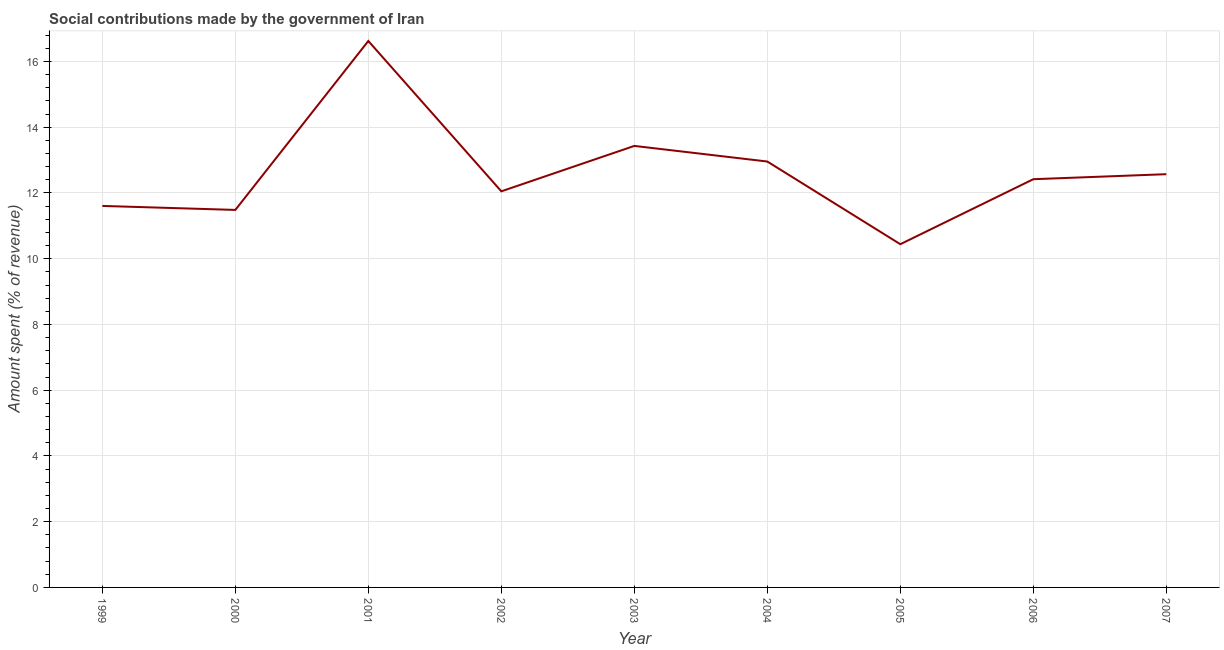What is the amount spent in making social contributions in 2005?
Your answer should be compact. 10.44. Across all years, what is the maximum amount spent in making social contributions?
Provide a short and direct response. 16.62. Across all years, what is the minimum amount spent in making social contributions?
Provide a succinct answer. 10.44. What is the sum of the amount spent in making social contributions?
Your response must be concise. 113.58. What is the difference between the amount spent in making social contributions in 2005 and 2006?
Your response must be concise. -1.98. What is the average amount spent in making social contributions per year?
Keep it short and to the point. 12.62. What is the median amount spent in making social contributions?
Make the answer very short. 12.42. In how many years, is the amount spent in making social contributions greater than 14.4 %?
Keep it short and to the point. 1. What is the ratio of the amount spent in making social contributions in 2000 to that in 2001?
Provide a succinct answer. 0.69. Is the amount spent in making social contributions in 2001 less than that in 2006?
Make the answer very short. No. What is the difference between the highest and the second highest amount spent in making social contributions?
Give a very brief answer. 3.19. What is the difference between the highest and the lowest amount spent in making social contributions?
Ensure brevity in your answer.  6.18. Does the amount spent in making social contributions monotonically increase over the years?
Provide a succinct answer. No. How many lines are there?
Ensure brevity in your answer.  1. Does the graph contain grids?
Offer a very short reply. Yes. What is the title of the graph?
Give a very brief answer. Social contributions made by the government of Iran. What is the label or title of the X-axis?
Give a very brief answer. Year. What is the label or title of the Y-axis?
Provide a short and direct response. Amount spent (% of revenue). What is the Amount spent (% of revenue) of 1999?
Give a very brief answer. 11.61. What is the Amount spent (% of revenue) in 2000?
Offer a very short reply. 11.48. What is the Amount spent (% of revenue) of 2001?
Offer a terse response. 16.62. What is the Amount spent (% of revenue) in 2002?
Keep it short and to the point. 12.05. What is the Amount spent (% of revenue) in 2003?
Offer a terse response. 13.43. What is the Amount spent (% of revenue) of 2004?
Offer a very short reply. 12.96. What is the Amount spent (% of revenue) in 2005?
Your response must be concise. 10.44. What is the Amount spent (% of revenue) in 2006?
Offer a terse response. 12.42. What is the Amount spent (% of revenue) of 2007?
Provide a short and direct response. 12.57. What is the difference between the Amount spent (% of revenue) in 1999 and 2000?
Give a very brief answer. 0.12. What is the difference between the Amount spent (% of revenue) in 1999 and 2001?
Give a very brief answer. -5.02. What is the difference between the Amount spent (% of revenue) in 1999 and 2002?
Your answer should be very brief. -0.44. What is the difference between the Amount spent (% of revenue) in 1999 and 2003?
Ensure brevity in your answer.  -1.83. What is the difference between the Amount spent (% of revenue) in 1999 and 2004?
Provide a short and direct response. -1.35. What is the difference between the Amount spent (% of revenue) in 1999 and 2005?
Offer a very short reply. 1.16. What is the difference between the Amount spent (% of revenue) in 1999 and 2006?
Your answer should be compact. -0.81. What is the difference between the Amount spent (% of revenue) in 1999 and 2007?
Your answer should be compact. -0.97. What is the difference between the Amount spent (% of revenue) in 2000 and 2001?
Your response must be concise. -5.14. What is the difference between the Amount spent (% of revenue) in 2000 and 2002?
Your answer should be compact. -0.57. What is the difference between the Amount spent (% of revenue) in 2000 and 2003?
Your answer should be compact. -1.95. What is the difference between the Amount spent (% of revenue) in 2000 and 2004?
Your response must be concise. -1.47. What is the difference between the Amount spent (% of revenue) in 2000 and 2005?
Ensure brevity in your answer.  1.04. What is the difference between the Amount spent (% of revenue) in 2000 and 2006?
Provide a succinct answer. -0.93. What is the difference between the Amount spent (% of revenue) in 2000 and 2007?
Your answer should be very brief. -1.09. What is the difference between the Amount spent (% of revenue) in 2001 and 2002?
Make the answer very short. 4.57. What is the difference between the Amount spent (% of revenue) in 2001 and 2003?
Offer a very short reply. 3.19. What is the difference between the Amount spent (% of revenue) in 2001 and 2004?
Give a very brief answer. 3.67. What is the difference between the Amount spent (% of revenue) in 2001 and 2005?
Ensure brevity in your answer.  6.18. What is the difference between the Amount spent (% of revenue) in 2001 and 2006?
Your answer should be compact. 4.2. What is the difference between the Amount spent (% of revenue) in 2001 and 2007?
Your answer should be very brief. 4.05. What is the difference between the Amount spent (% of revenue) in 2002 and 2003?
Your response must be concise. -1.38. What is the difference between the Amount spent (% of revenue) in 2002 and 2004?
Your answer should be very brief. -0.91. What is the difference between the Amount spent (% of revenue) in 2002 and 2005?
Your answer should be compact. 1.61. What is the difference between the Amount spent (% of revenue) in 2002 and 2006?
Your answer should be compact. -0.37. What is the difference between the Amount spent (% of revenue) in 2002 and 2007?
Your answer should be very brief. -0.52. What is the difference between the Amount spent (% of revenue) in 2003 and 2004?
Offer a very short reply. 0.47. What is the difference between the Amount spent (% of revenue) in 2003 and 2005?
Make the answer very short. 2.99. What is the difference between the Amount spent (% of revenue) in 2003 and 2006?
Make the answer very short. 1.01. What is the difference between the Amount spent (% of revenue) in 2003 and 2007?
Provide a succinct answer. 0.86. What is the difference between the Amount spent (% of revenue) in 2004 and 2005?
Keep it short and to the point. 2.52. What is the difference between the Amount spent (% of revenue) in 2004 and 2006?
Ensure brevity in your answer.  0.54. What is the difference between the Amount spent (% of revenue) in 2004 and 2007?
Your response must be concise. 0.39. What is the difference between the Amount spent (% of revenue) in 2005 and 2006?
Provide a succinct answer. -1.98. What is the difference between the Amount spent (% of revenue) in 2005 and 2007?
Give a very brief answer. -2.13. What is the difference between the Amount spent (% of revenue) in 2006 and 2007?
Offer a very short reply. -0.15. What is the ratio of the Amount spent (% of revenue) in 1999 to that in 2001?
Offer a terse response. 0.7. What is the ratio of the Amount spent (% of revenue) in 1999 to that in 2003?
Your answer should be compact. 0.86. What is the ratio of the Amount spent (% of revenue) in 1999 to that in 2004?
Make the answer very short. 0.9. What is the ratio of the Amount spent (% of revenue) in 1999 to that in 2005?
Your response must be concise. 1.11. What is the ratio of the Amount spent (% of revenue) in 1999 to that in 2006?
Your answer should be very brief. 0.94. What is the ratio of the Amount spent (% of revenue) in 1999 to that in 2007?
Keep it short and to the point. 0.92. What is the ratio of the Amount spent (% of revenue) in 2000 to that in 2001?
Your response must be concise. 0.69. What is the ratio of the Amount spent (% of revenue) in 2000 to that in 2002?
Make the answer very short. 0.95. What is the ratio of the Amount spent (% of revenue) in 2000 to that in 2003?
Ensure brevity in your answer.  0.85. What is the ratio of the Amount spent (% of revenue) in 2000 to that in 2004?
Your response must be concise. 0.89. What is the ratio of the Amount spent (% of revenue) in 2000 to that in 2005?
Your response must be concise. 1.1. What is the ratio of the Amount spent (% of revenue) in 2000 to that in 2006?
Offer a very short reply. 0.93. What is the ratio of the Amount spent (% of revenue) in 2000 to that in 2007?
Make the answer very short. 0.91. What is the ratio of the Amount spent (% of revenue) in 2001 to that in 2002?
Make the answer very short. 1.38. What is the ratio of the Amount spent (% of revenue) in 2001 to that in 2003?
Your response must be concise. 1.24. What is the ratio of the Amount spent (% of revenue) in 2001 to that in 2004?
Your response must be concise. 1.28. What is the ratio of the Amount spent (% of revenue) in 2001 to that in 2005?
Keep it short and to the point. 1.59. What is the ratio of the Amount spent (% of revenue) in 2001 to that in 2006?
Your answer should be very brief. 1.34. What is the ratio of the Amount spent (% of revenue) in 2001 to that in 2007?
Offer a very short reply. 1.32. What is the ratio of the Amount spent (% of revenue) in 2002 to that in 2003?
Your answer should be very brief. 0.9. What is the ratio of the Amount spent (% of revenue) in 2002 to that in 2005?
Give a very brief answer. 1.15. What is the ratio of the Amount spent (% of revenue) in 2003 to that in 2005?
Your response must be concise. 1.29. What is the ratio of the Amount spent (% of revenue) in 2003 to that in 2006?
Provide a succinct answer. 1.08. What is the ratio of the Amount spent (% of revenue) in 2003 to that in 2007?
Your response must be concise. 1.07. What is the ratio of the Amount spent (% of revenue) in 2004 to that in 2005?
Your answer should be very brief. 1.24. What is the ratio of the Amount spent (% of revenue) in 2004 to that in 2006?
Give a very brief answer. 1.04. What is the ratio of the Amount spent (% of revenue) in 2004 to that in 2007?
Give a very brief answer. 1.03. What is the ratio of the Amount spent (% of revenue) in 2005 to that in 2006?
Offer a very short reply. 0.84. What is the ratio of the Amount spent (% of revenue) in 2005 to that in 2007?
Offer a very short reply. 0.83. What is the ratio of the Amount spent (% of revenue) in 2006 to that in 2007?
Offer a terse response. 0.99. 